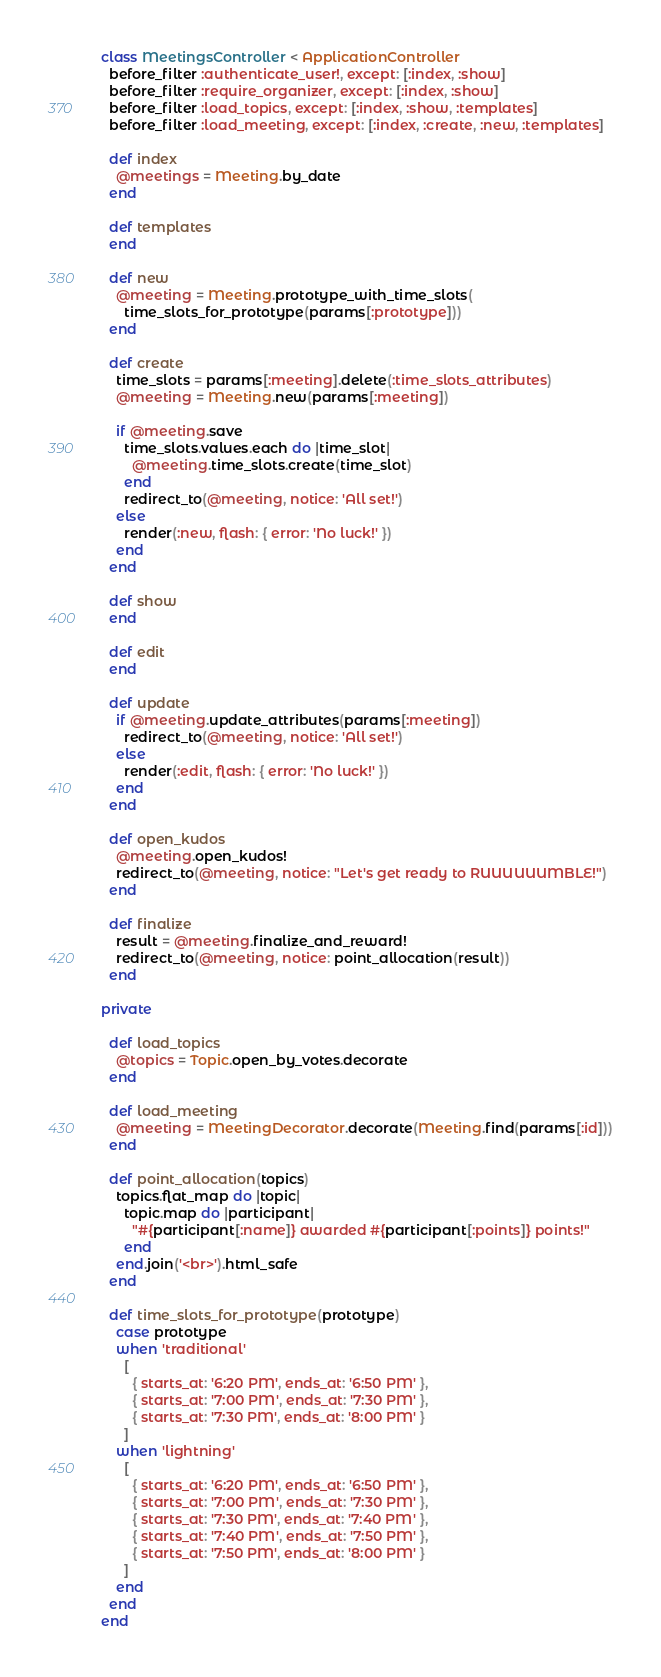<code> <loc_0><loc_0><loc_500><loc_500><_Ruby_>class MeetingsController < ApplicationController
  before_filter :authenticate_user!, except: [:index, :show]
  before_filter :require_organizer, except: [:index, :show]
  before_filter :load_topics, except: [:index, :show, :templates]
  before_filter :load_meeting, except: [:index, :create, :new, :templates]

  def index
    @meetings = Meeting.by_date
  end

  def templates
  end

  def new
    @meeting = Meeting.prototype_with_time_slots(
      time_slots_for_prototype(params[:prototype]))
  end

  def create
    time_slots = params[:meeting].delete(:time_slots_attributes)
    @meeting = Meeting.new(params[:meeting])

    if @meeting.save
      time_slots.values.each do |time_slot|
        @meeting.time_slots.create(time_slot)
      end
      redirect_to(@meeting, notice: 'All set!')
    else
      render(:new, flash: { error: 'No luck!' })
    end
  end

  def show
  end

  def edit
  end

  def update
    if @meeting.update_attributes(params[:meeting])
      redirect_to(@meeting, notice: 'All set!')
    else
      render(:edit, flash: { error: 'No luck!' })
    end
  end

  def open_kudos
    @meeting.open_kudos!
    redirect_to(@meeting, notice: "Let's get ready to RUUUUUUMBLE!")
  end

  def finalize
    result = @meeting.finalize_and_reward!
    redirect_to(@meeting, notice: point_allocation(result))
  end

private

  def load_topics
    @topics = Topic.open_by_votes.decorate
  end

  def load_meeting
    @meeting = MeetingDecorator.decorate(Meeting.find(params[:id]))
  end

  def point_allocation(topics)
    topics.flat_map do |topic|
      topic.map do |participant|
        "#{participant[:name]} awarded #{participant[:points]} points!"
      end
    end.join('<br>').html_safe
  end

  def time_slots_for_prototype(prototype)
    case prototype
    when 'traditional'
      [
        { starts_at: '6:20 PM', ends_at: '6:50 PM' },
        { starts_at: '7:00 PM', ends_at: '7:30 PM' },
        { starts_at: '7:30 PM', ends_at: '8:00 PM' }
      ]
    when 'lightning'
      [
        { starts_at: '6:20 PM', ends_at: '6:50 PM' },
        { starts_at: '7:00 PM', ends_at: '7:30 PM' },
        { starts_at: '7:30 PM', ends_at: '7:40 PM' },
        { starts_at: '7:40 PM', ends_at: '7:50 PM' },
        { starts_at: '7:50 PM', ends_at: '8:00 PM' }
      ]
    end
  end
end
</code> 